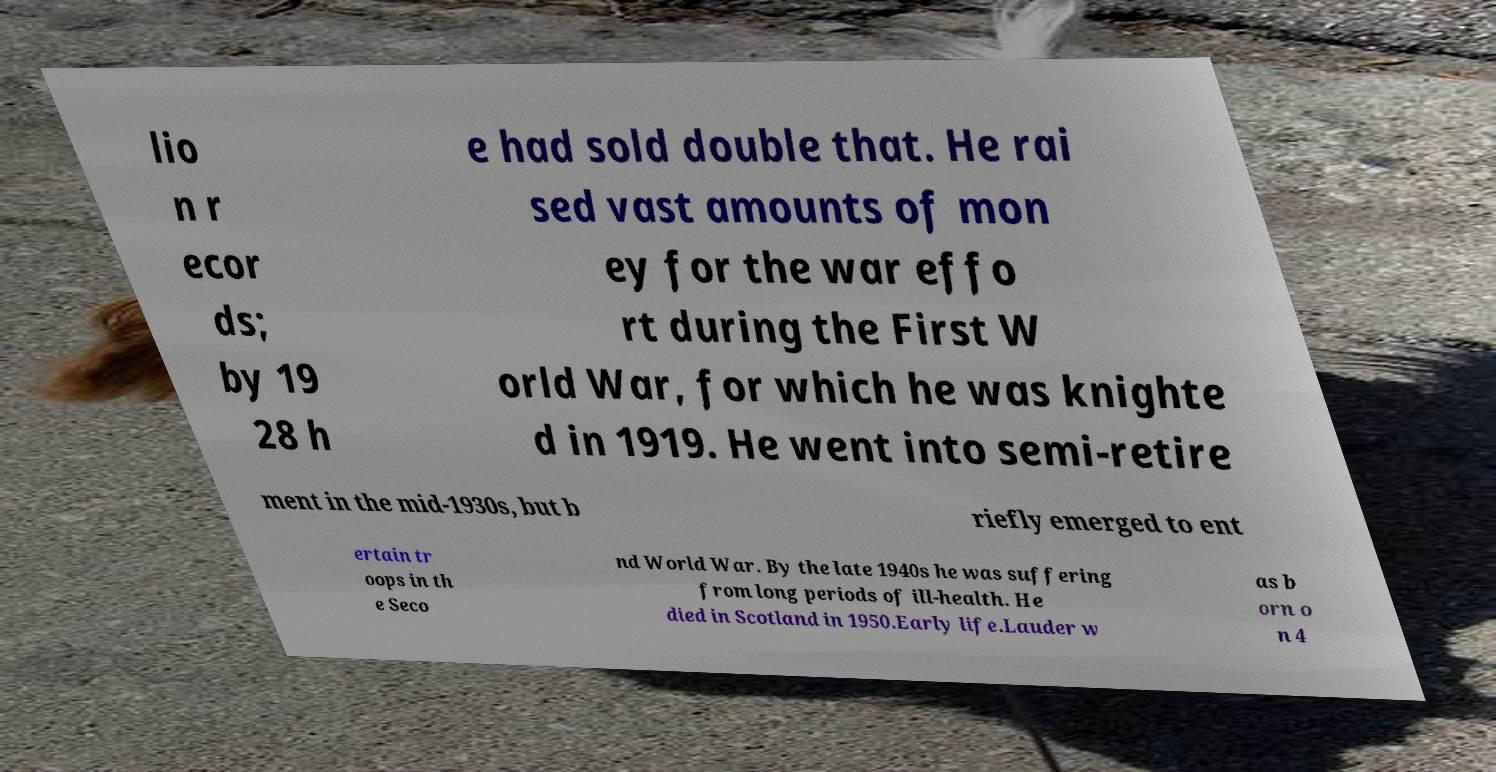Please read and relay the text visible in this image. What does it say? lio n r ecor ds; by 19 28 h e had sold double that. He rai sed vast amounts of mon ey for the war effo rt during the First W orld War, for which he was knighte d in 1919. He went into semi-retire ment in the mid-1930s, but b riefly emerged to ent ertain tr oops in th e Seco nd World War. By the late 1940s he was suffering from long periods of ill-health. He died in Scotland in 1950.Early life.Lauder w as b orn o n 4 